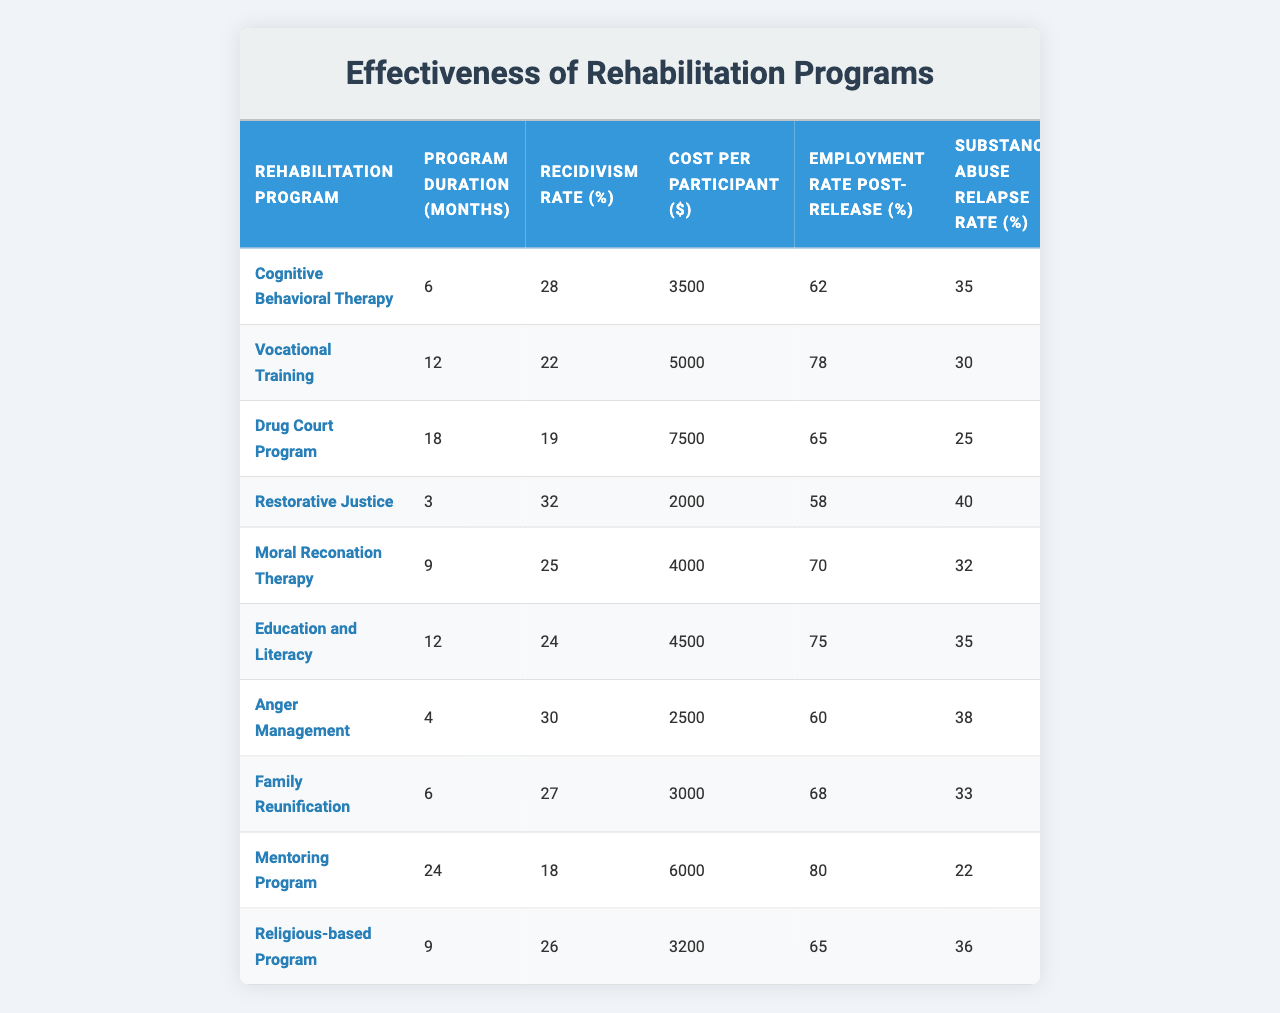What is the recidivism rate for the Drug Court Program? The recidivism rate is specifically indicated in the table. For the Drug Court Program, it states a recidivism rate of 19%.
Answer: 19% Which rehabilitation program has the highest employment rate post-release? The table lists the employment rates post-release for each program. The Vocational Training program shows the highest employment rate at 78%.
Answer: 78% What is the average cost per participant for all rehabilitation programs? To find the average cost, we add up all the costs per participant: 3500 + 5000 + 7500 + 2000 + 4000 + 4500 + 2500 + 3000 + 6000 + 3200 = 35000. Then, divide by the number of programs (10), which gives an average of 35000/10 = 3500.
Answer: 3500 Is the recidivism rate for Cognitive Behavioral Therapy higher than for Moral Reconation Therapy? The recidivism rate for Cognitive Behavioral Therapy is 28%, and for Moral Reconation Therapy, it is 25%. Since 28% is greater than 25%, the statement is true.
Answer: Yes What is the difference in recidivism rates between the Mentoring Program and the Vocational Training program? The recidivism rate for the Mentoring Program is 18%, and for Vocational Training, it is 22%. The difference is calculated by subtracting the recidivism rate of Vocational Training from that of the Mentoring Program: 22 - 18 = 4%.
Answer: 4% Which program has the lowest substance abuse relapse rate, and what is that rate? The table shows the substance abuse relapse rates for each program. The Drug Court Program has the lowest relapse rate at 25%.
Answer: Drug Court Program, 25% If a program needed to be selected based on both low recidivism and low relapse rates, which program would be the best choice? The Drug Court Program has the lowest recidivism rate (19%) and a lower than average relapse rate (25%). Other programs like the Mentoring Program have a lower recidivism rate but a higher relapse rate. The Drug Court Program thus stands out as a balanced choice.
Answer: Drug Court Program What is the total duration of the Vocational Training and Family Reunification programs combined? To find the total duration, we add the durations of both programs: Vocational Training is 12 months and Family Reunification is 6 months. Thus, the total is 12 + 6 = 18 months.
Answer: 18 months Is it true that programs with shorter durations tend to have higher recidivism rates? By examining the table, we can see that the programs with shorter durations, like Restorative Justice (3 months) and Anger Management (4 months), have higher recidivism rates (32% and 30%). Thus, the statement appears to be true as a trend but may not apply universally to every short duration program.
Answer: True What is the average recidivism rate for programs lasting 12 months or longer? The programs lasting 12 months or longer are Vocational Training (22%), Drug Court Program (19%), and Mentoring Program (18%). To find the average: (22 + 19 + 18) / 3 = 19.67%.
Answer: 19.67% 